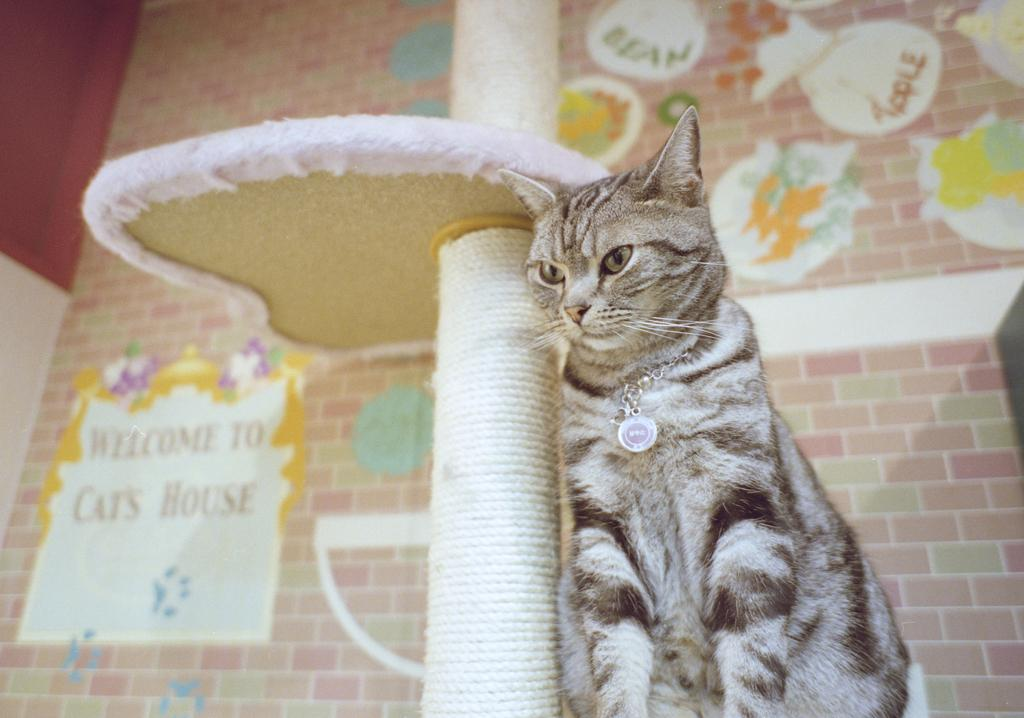What animal is present in the image? There is a cat in the image. Where is the cat located in the image? The cat is in the middle of the image. What can be seen in the background of the image? There is a wall in the image. What type of wood can be seen in the image? There is no wood present in the image; it features a cat and a wall. How many elbows can be seen in the image? There are no elbows visible in the image, as it features a cat and a wall. 